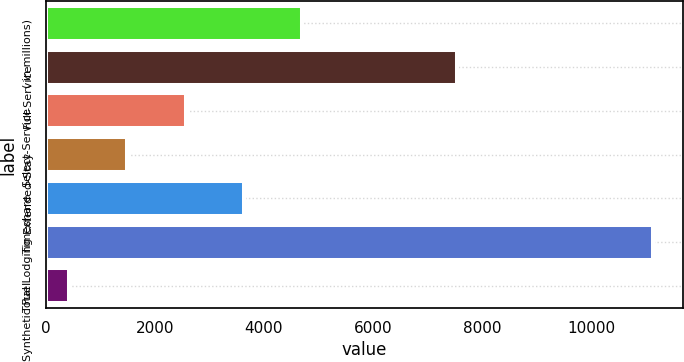Convert chart. <chart><loc_0><loc_0><loc_500><loc_500><bar_chart><fcel>( in millions)<fcel>Full-Service<fcel>Select-Service<fcel>Extended-Stay<fcel>Timeshare<fcel>Total Lodging<fcel>Synthetic Fuel<nl><fcel>4704.2<fcel>7535<fcel>2562.6<fcel>1491.8<fcel>3633.4<fcel>11129<fcel>421<nl></chart> 